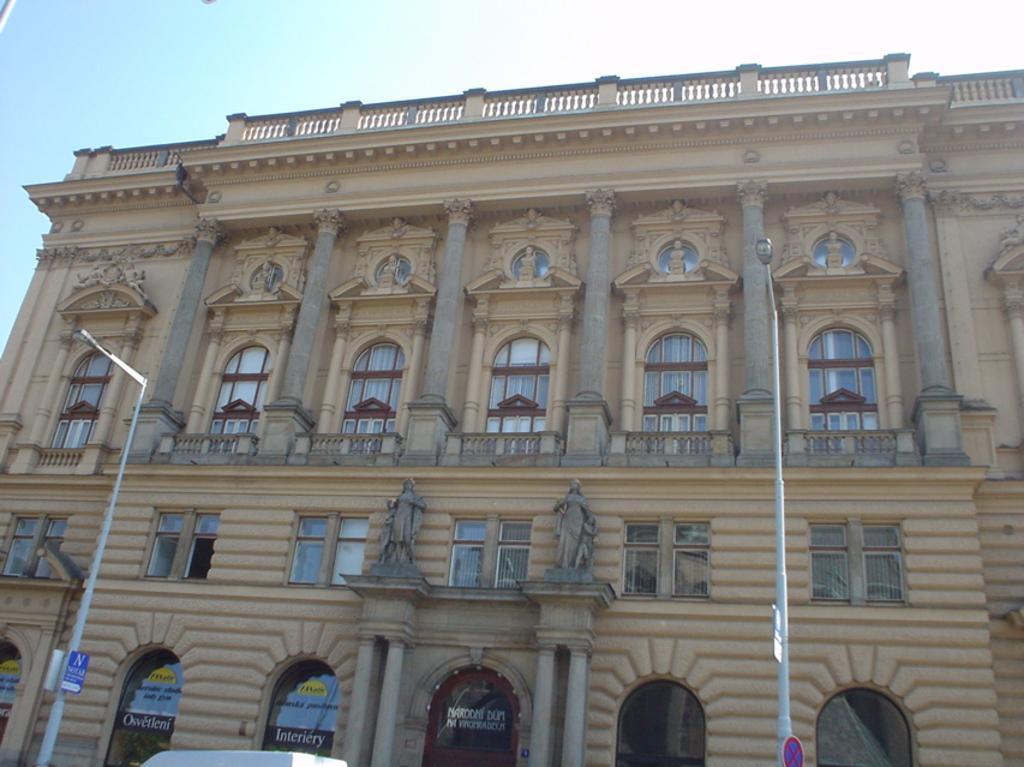Describe this image in one or two sentences. In this image I can see the building with windows. I can see the statues on the building. I can also see something is written on the glass of the building. In the front there are light poles and in the back I can see the sky. 